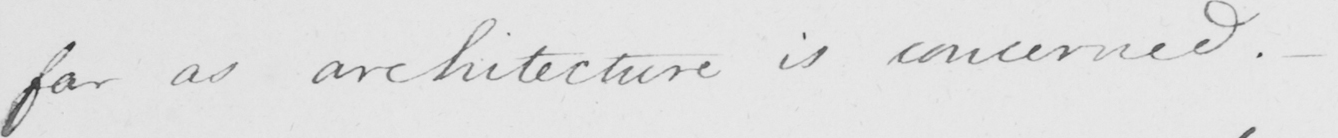What text is written in this handwritten line? far as architecture is concerned .  _ 